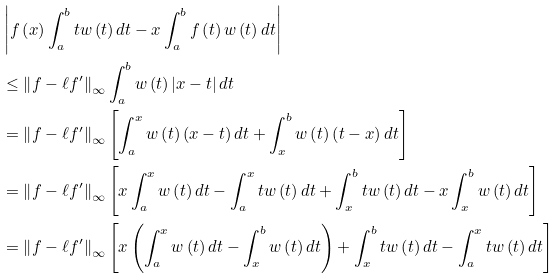<formula> <loc_0><loc_0><loc_500><loc_500>& \left | f \left ( x \right ) \int _ { a } ^ { b } t w \left ( t \right ) d t - x \int _ { a } ^ { b } f \left ( t \right ) w \left ( t \right ) d t \right | \\ & \leq \left \| f - \ell f ^ { \prime } \right \| _ { \infty } \int _ { a } ^ { b } w \left ( t \right ) \left | x - t \right | d t \\ & = \left \| f - \ell f ^ { \prime } \right \| _ { \infty } \left [ \int _ { a } ^ { x } w \left ( t \right ) \left ( x - t \right ) d t + \int _ { x } ^ { b } w \left ( t \right ) \left ( t - x \right ) d t \right ] \\ & = \left \| f - \ell f ^ { \prime } \right \| _ { \infty } \left [ x \int _ { a } ^ { x } w \left ( t \right ) d t - \int _ { a } ^ { x } t w \left ( t \right ) d t + \int _ { x } ^ { b } t w \left ( t \right ) d t - x \int _ { x } ^ { b } w \left ( t \right ) d t \right ] \\ & = \left \| f - \ell f ^ { \prime } \right \| _ { \infty } \left [ x \left ( \int _ { a } ^ { x } w \left ( t \right ) d t - \int _ { x } ^ { b } w \left ( t \right ) d t \right ) + \int _ { x } ^ { b } t w \left ( t \right ) d t - \int _ { a } ^ { x } t w \left ( t \right ) d t \right ]</formula> 